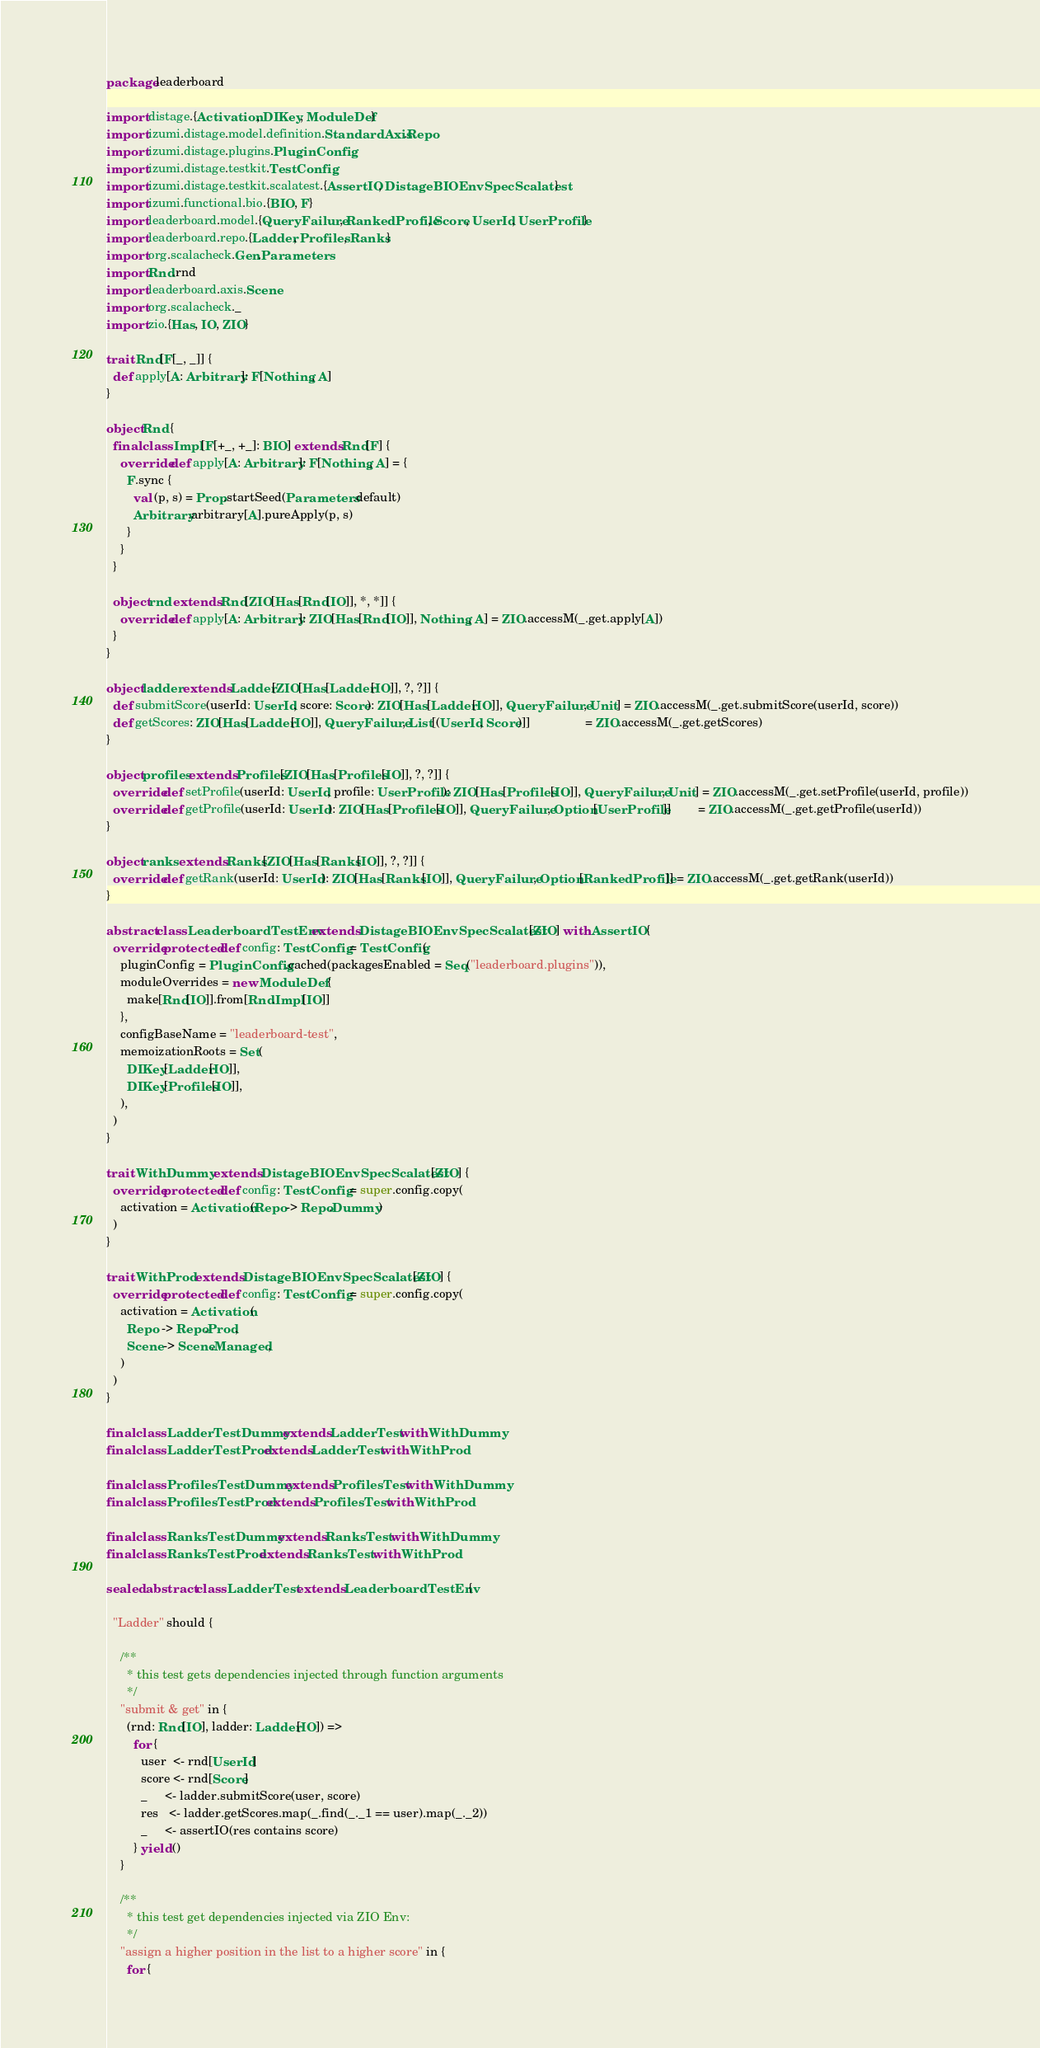Convert code to text. <code><loc_0><loc_0><loc_500><loc_500><_Scala_>package leaderboard

import distage.{Activation, DIKey, ModuleDef}
import izumi.distage.model.definition.StandardAxis.Repo
import izumi.distage.plugins.PluginConfig
import izumi.distage.testkit.TestConfig
import izumi.distage.testkit.scalatest.{AssertIO, DistageBIOEnvSpecScalatest}
import izumi.functional.bio.{BIO, F}
import leaderboard.model.{QueryFailure, RankedProfile, Score, UserId, UserProfile}
import leaderboard.repo.{Ladder, Profiles, Ranks}
import org.scalacheck.Gen.Parameters
import Rnd.rnd
import leaderboard.axis.Scene
import org.scalacheck._
import zio.{Has, IO, ZIO}

trait Rnd[F[_, _]] {
  def apply[A: Arbitrary]: F[Nothing, A]
}

object Rnd {
  final class Impl[F[+_, +_]: BIO] extends Rnd[F] {
    override def apply[A: Arbitrary]: F[Nothing, A] = {
      F.sync {
        val (p, s) = Prop.startSeed(Parameters.default)
        Arbitrary.arbitrary[A].pureApply(p, s)
      }
    }
  }

  object rnd extends Rnd[ZIO[Has[Rnd[IO]], *, *]] {
    override def apply[A: Arbitrary]: ZIO[Has[Rnd[IO]], Nothing, A] = ZIO.accessM(_.get.apply[A])
  }
}

object ladder extends Ladder[ZIO[Has[Ladder[IO]], ?, ?]] {
  def submitScore(userId: UserId, score: Score): ZIO[Has[Ladder[IO]], QueryFailure, Unit] = ZIO.accessM(_.get.submitScore(userId, score))
  def getScores: ZIO[Has[Ladder[IO]], QueryFailure, List[(UserId, Score)]]                = ZIO.accessM(_.get.getScores)
}

object profiles extends Profiles[ZIO[Has[Profiles[IO]], ?, ?]] {
  override def setProfile(userId: UserId, profile: UserProfile): ZIO[Has[Profiles[IO]], QueryFailure, Unit] = ZIO.accessM(_.get.setProfile(userId, profile))
  override def getProfile(userId: UserId): ZIO[Has[Profiles[IO]], QueryFailure, Option[UserProfile]]        = ZIO.accessM(_.get.getProfile(userId))
}

object ranks extends Ranks[ZIO[Has[Ranks[IO]], ?, ?]] {
  override def getRank(userId: UserId): ZIO[Has[Ranks[IO]], QueryFailure, Option[RankedProfile]] = ZIO.accessM(_.get.getRank(userId))
}

abstract class LeaderboardTestEnv extends DistageBIOEnvSpecScalatest[ZIO] with AssertIO {
  override protected def config: TestConfig = TestConfig(
    pluginConfig = PluginConfig.cached(packagesEnabled = Seq("leaderboard.plugins")),
    moduleOverrides = new ModuleDef {
      make[Rnd[IO]].from[Rnd.Impl[IO]]
    },
    configBaseName = "leaderboard-test",
    memoizationRoots = Set(
      DIKey[Ladder[IO]],
      DIKey[Profiles[IO]],
    ),
  )
}

trait WithDummy extends DistageBIOEnvSpecScalatest[ZIO] {
  override protected def config: TestConfig = super.config.copy(
    activation = Activation(Repo -> Repo.Dummy)
  )
}

trait WithProd extends DistageBIOEnvSpecScalatest[ZIO] {
  override protected def config: TestConfig = super.config.copy(
    activation = Activation(
      Repo  -> Repo.Prod,
      Scene -> Scene.Managed,
    )
  )
}

final class LadderTestDummy extends LadderTest with WithDummy
final class LadderTestProd extends LadderTest with WithProd

final class ProfilesTestDummy extends ProfilesTest with WithDummy
final class ProfilesTestProd extends ProfilesTest with WithProd

final class RanksTestDummy extends RanksTest with WithDummy
final class RanksTestProd extends RanksTest with WithProd

sealed abstract class LadderTest extends LeaderboardTestEnv {

  "Ladder" should {

    /**
      * this test gets dependencies injected through function arguments
      */
    "submit & get" in {
      (rnd: Rnd[IO], ladder: Ladder[IO]) =>
        for {
          user  <- rnd[UserId]
          score <- rnd[Score]
          _     <- ladder.submitScore(user, score)
          res   <- ladder.getScores.map(_.find(_._1 == user).map(_._2))
          _     <- assertIO(res contains score)
        } yield ()
    }

    /**
      * this test get dependencies injected via ZIO Env:
      */
    "assign a higher position in the list to a higher score" in {
      for {</code> 